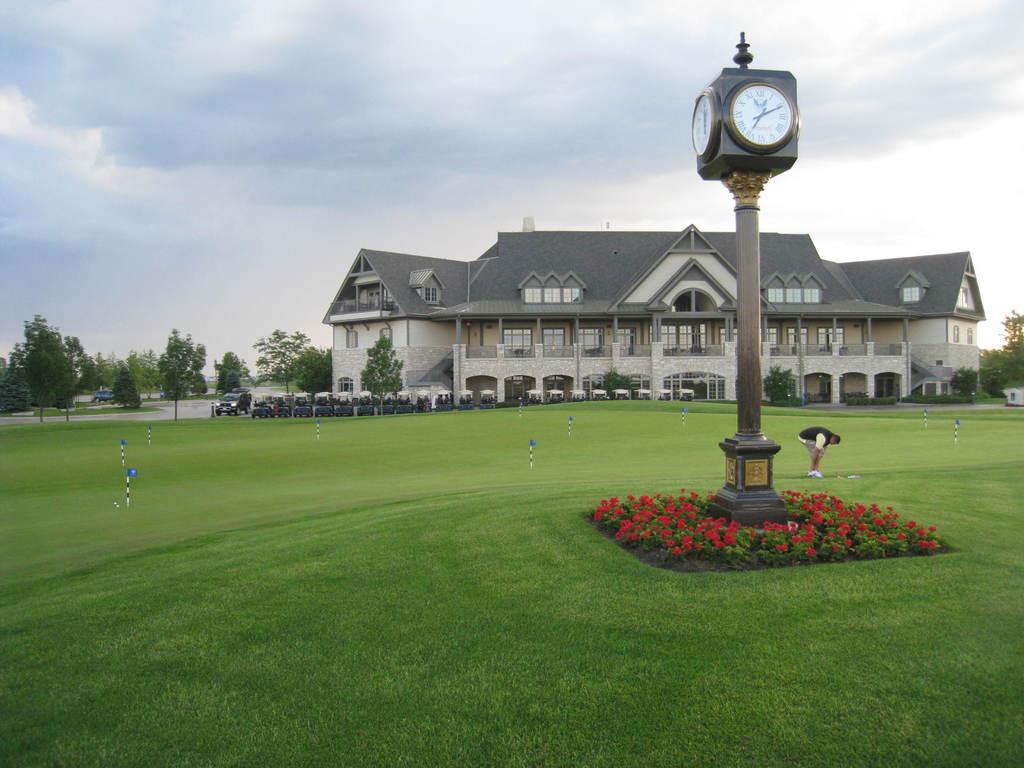Can you describe this image briefly? There is a clock tower. Near to that there are flowering plants. There is grass lawn. In the background there is a vehicle, building with windows, pillars. Also there are trees and sky. 